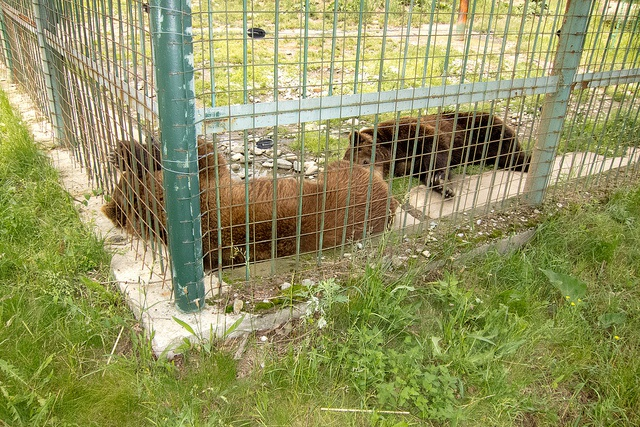Describe the objects in this image and their specific colors. I can see bear in olive, maroon, gray, and tan tones and bear in olive, black, tan, and maroon tones in this image. 